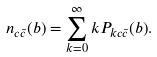<formula> <loc_0><loc_0><loc_500><loc_500>n _ { c \bar { c } } ( b ) = \sum _ { k = 0 } ^ { \infty } k P _ { k c \bar { c } } ( b ) .</formula> 